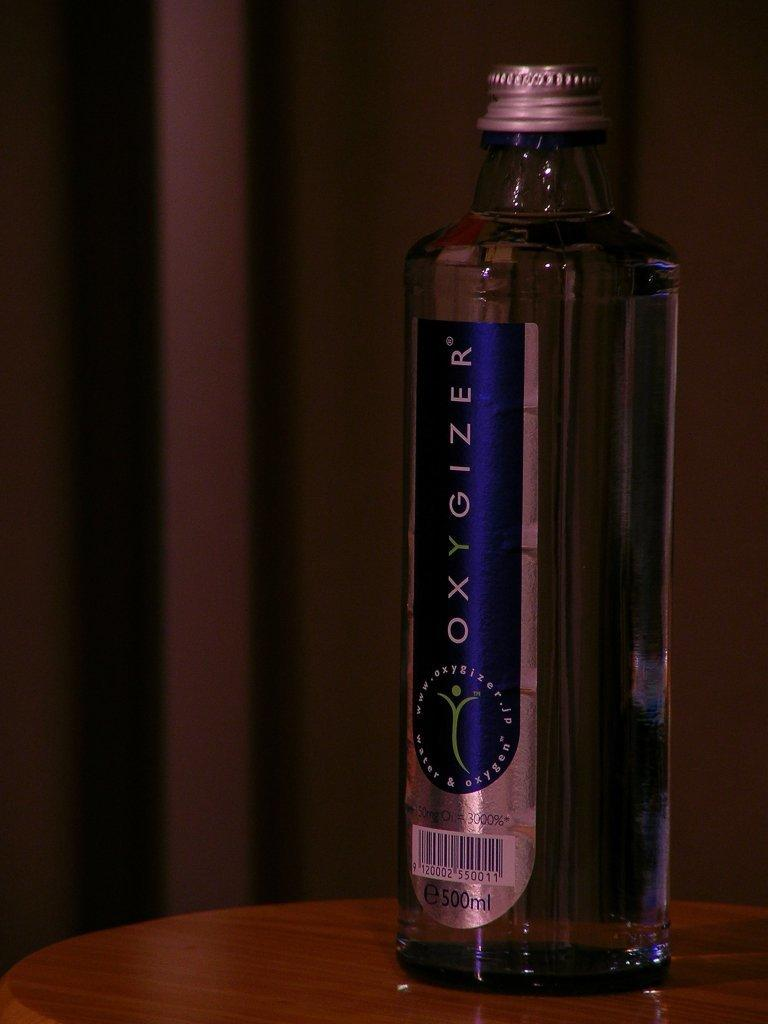What object can be seen in the image? There is a bottle in the image. Where is the bottle located? The bottle is placed on a table. How many zippers can be seen on the bottle in the image? There are no zippers present on the bottle in the image. What type of giants are depicted in the image? There are no giants depicted in the image; it only features a bottle placed on a table. 